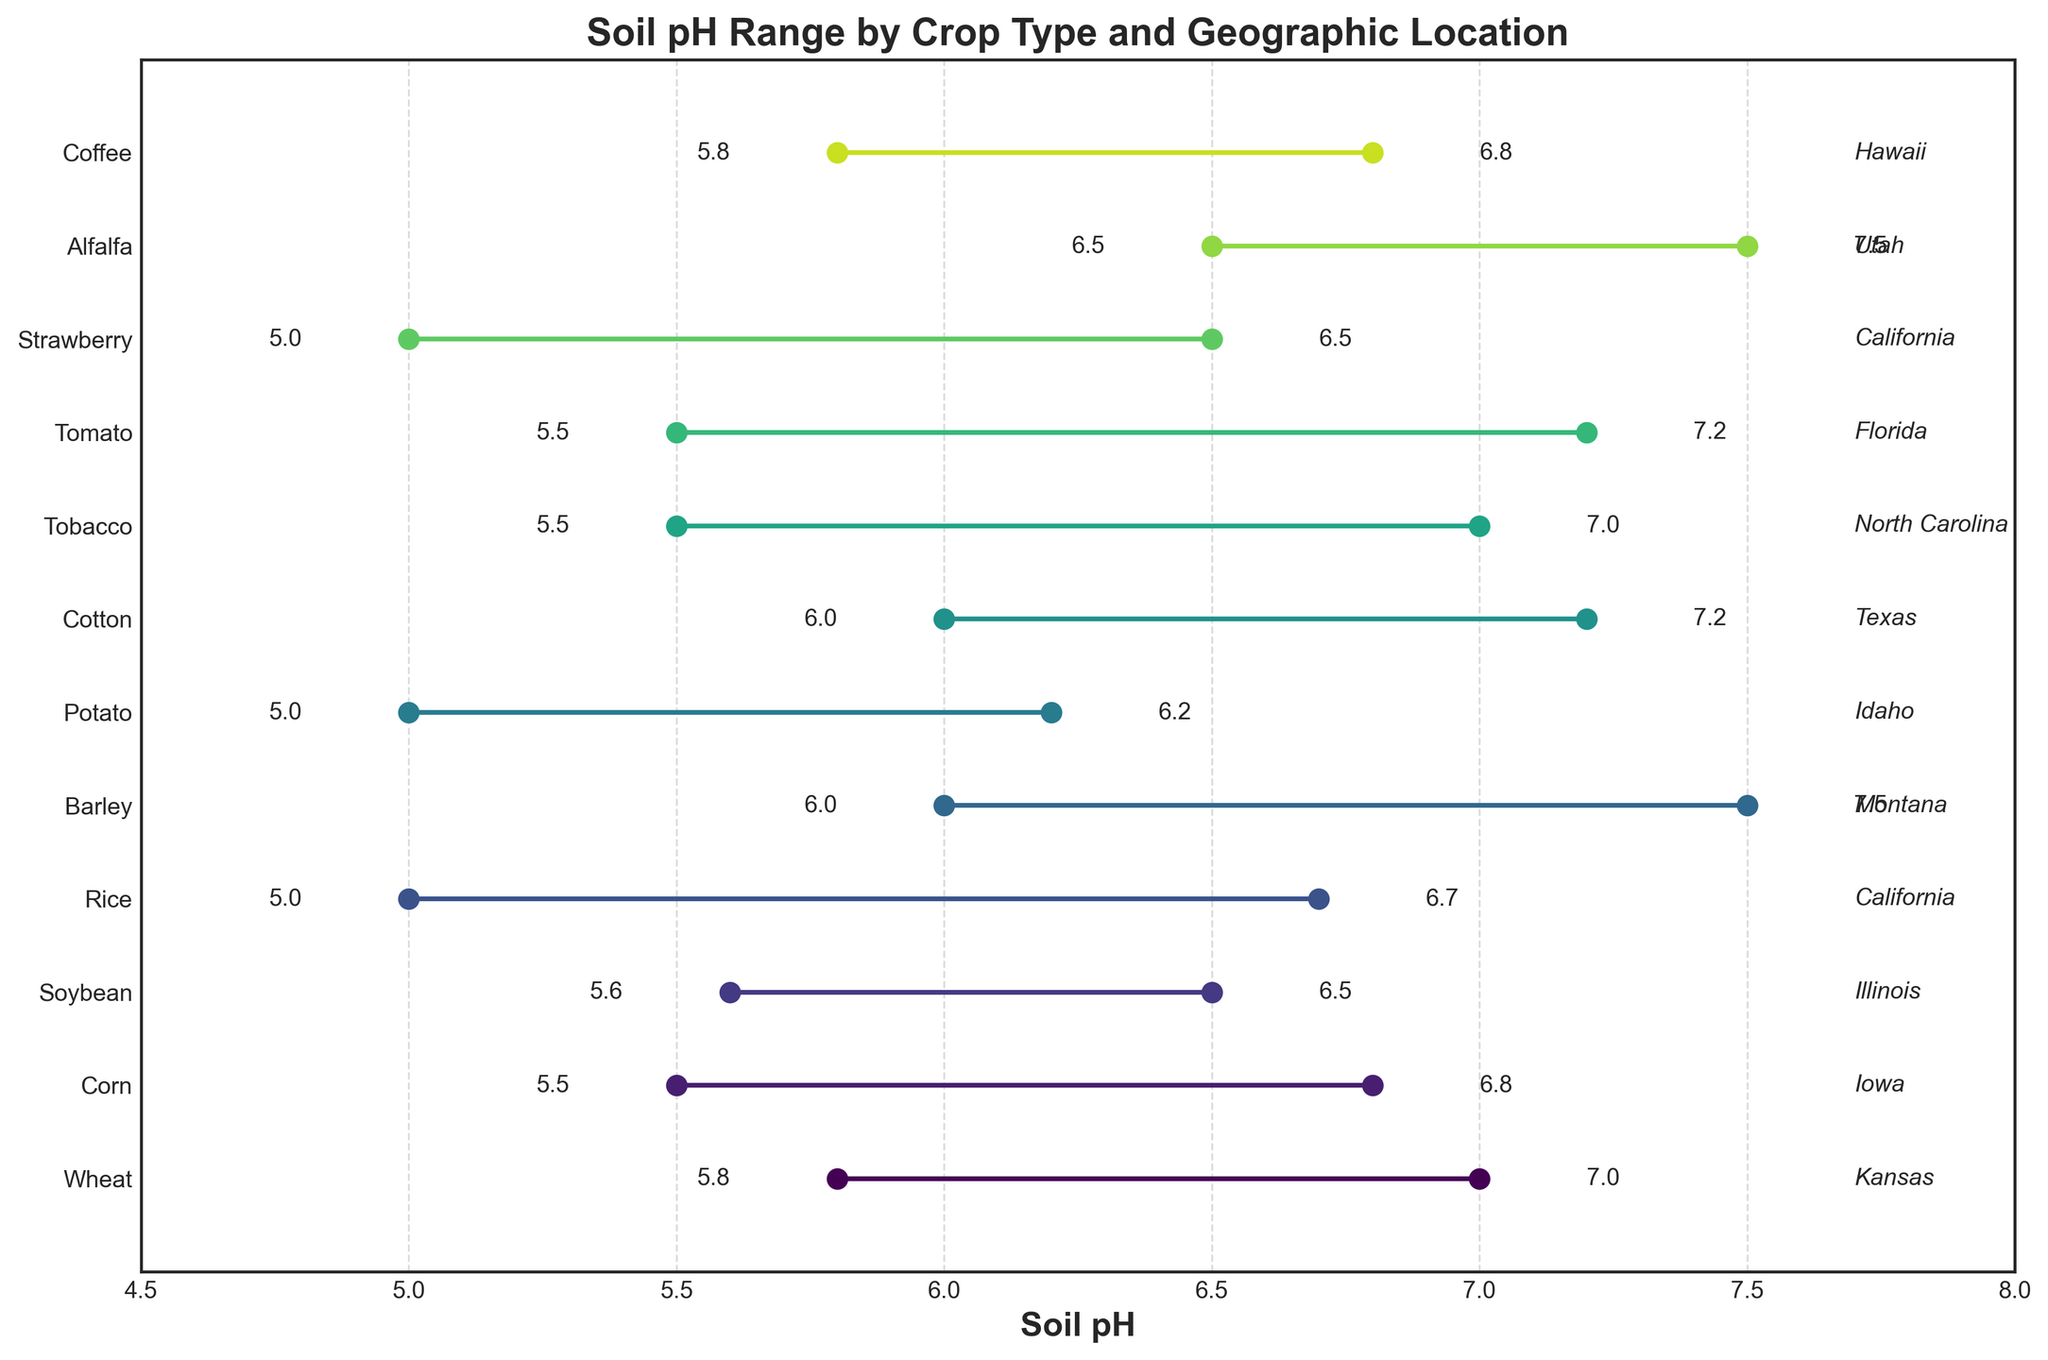What's the title of the plot? The title of the plot is usually displayed at the top of the figure. From the code, it is set to "Soil pH Range by Crop Type and Geographic Location".
Answer: Soil pH Range by Crop Type and Geographic Location Which crop has the widest pH range? To find the crop with the widest pH range, look for the longest horizontal line on the plot. Barley has a range from 6.0 to 7.5, which is the largest span.
Answer: Barley What is the pH range for Coffee in Hawaii? To find this, locate "Coffee" on the y-axis and check the horizontal line that corresponds to it. The pH range for Coffee in Hawaii is from 5.8 to 6.8.
Answer: 5.8 to 6.8 Which crop has the lowest minimum pH? To determine the crop with the lowest minimum pH, identify the leftmost dot across all the horizontal lines. Rice and Strawberry both have a minimum pH of 5.0.
Answer: Rice and Strawberry What is the average maximum pH value for crops in California? Identify the crops located in California (Rice and Strawberry). Their maximum pH values are 6.7 and 6.5, respectively. The average is (6.7 + 6.5) / 2 = 6.6.
Answer: 6.6 Which crop in Kansas has a pH range overlapping with that of Cotton in Texas? Look at the pH range for Wheat in Kansas and Cotton in Texas. Wheat ranges from 5.8 to 7.0, and Cotton ranges from 6.0 to 7.2. These ranges overlap.
Answer: Wheat What is the total number of crops with a maximum pH above 7.0? Count the crops whose rightmost dot (maximum pH) is greater than 7.0. These are Wheat, Barley, Cotton, Tobacco, Tomato, and Alfalfa, totaling six crops.
Answer: 6 Which geographic location is associated with the crop that has the smallest pH range? Identify the crop with the shortest horizontal line. Soybean in Illinois ranges from 5.6 to 6.5, with a range of 0.9 units, which is the smallest.
Answer: Illinois 